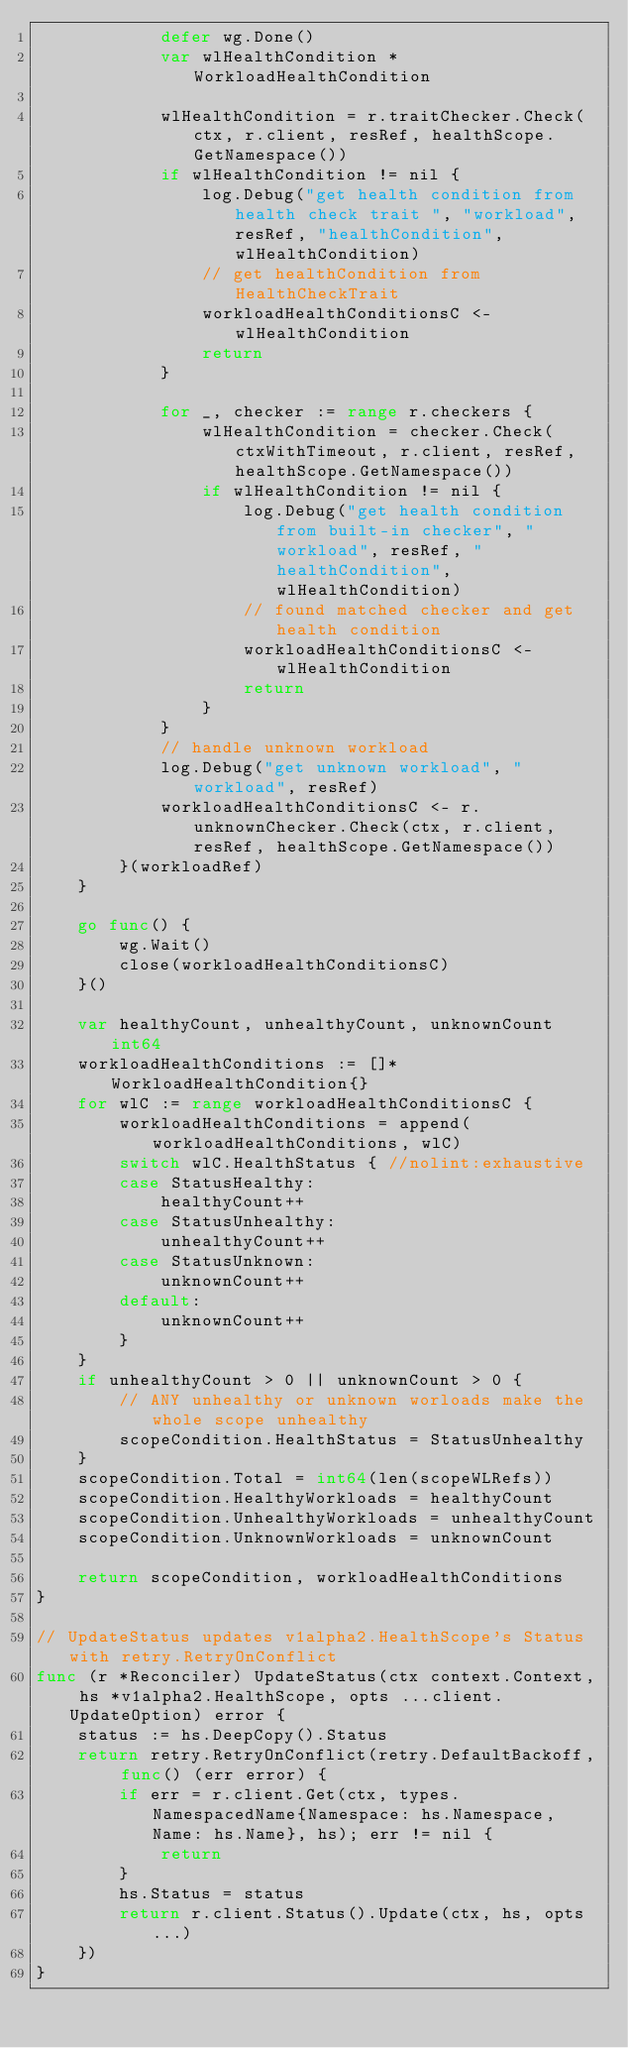<code> <loc_0><loc_0><loc_500><loc_500><_Go_>			defer wg.Done()
			var wlHealthCondition *WorkloadHealthCondition

			wlHealthCondition = r.traitChecker.Check(ctx, r.client, resRef, healthScope.GetNamespace())
			if wlHealthCondition != nil {
				log.Debug("get health condition from health check trait ", "workload", resRef, "healthCondition", wlHealthCondition)
				// get healthCondition from HealthCheckTrait
				workloadHealthConditionsC <- wlHealthCondition
				return
			}

			for _, checker := range r.checkers {
				wlHealthCondition = checker.Check(ctxWithTimeout, r.client, resRef, healthScope.GetNamespace())
				if wlHealthCondition != nil {
					log.Debug("get health condition from built-in checker", "workload", resRef, "healthCondition", wlHealthCondition)
					// found matched checker and get health condition
					workloadHealthConditionsC <- wlHealthCondition
					return
				}
			}
			// handle unknown workload
			log.Debug("get unknown workload", "workload", resRef)
			workloadHealthConditionsC <- r.unknownChecker.Check(ctx, r.client, resRef, healthScope.GetNamespace())
		}(workloadRef)
	}

	go func() {
		wg.Wait()
		close(workloadHealthConditionsC)
	}()

	var healthyCount, unhealthyCount, unknownCount int64
	workloadHealthConditions := []*WorkloadHealthCondition{}
	for wlC := range workloadHealthConditionsC {
		workloadHealthConditions = append(workloadHealthConditions, wlC)
		switch wlC.HealthStatus { //nolint:exhaustive
		case StatusHealthy:
			healthyCount++
		case StatusUnhealthy:
			unhealthyCount++
		case StatusUnknown:
			unknownCount++
		default:
			unknownCount++
		}
	}
	if unhealthyCount > 0 || unknownCount > 0 {
		// ANY unhealthy or unknown worloads make the whole scope unhealthy
		scopeCondition.HealthStatus = StatusUnhealthy
	}
	scopeCondition.Total = int64(len(scopeWLRefs))
	scopeCondition.HealthyWorkloads = healthyCount
	scopeCondition.UnhealthyWorkloads = unhealthyCount
	scopeCondition.UnknownWorkloads = unknownCount

	return scopeCondition, workloadHealthConditions
}

// UpdateStatus updates v1alpha2.HealthScope's Status with retry.RetryOnConflict
func (r *Reconciler) UpdateStatus(ctx context.Context, hs *v1alpha2.HealthScope, opts ...client.UpdateOption) error {
	status := hs.DeepCopy().Status
	return retry.RetryOnConflict(retry.DefaultBackoff, func() (err error) {
		if err = r.client.Get(ctx, types.NamespacedName{Namespace: hs.Namespace, Name: hs.Name}, hs); err != nil {
			return
		}
		hs.Status = status
		return r.client.Status().Update(ctx, hs, opts...)
	})
}
</code> 